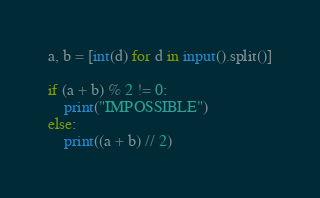Convert code to text. <code><loc_0><loc_0><loc_500><loc_500><_Python_>a, b = [int(d) for d in input().split()]

if (a + b) % 2 != 0:
    print("IMPOSSIBLE")
else:
    print((a + b) // 2)</code> 